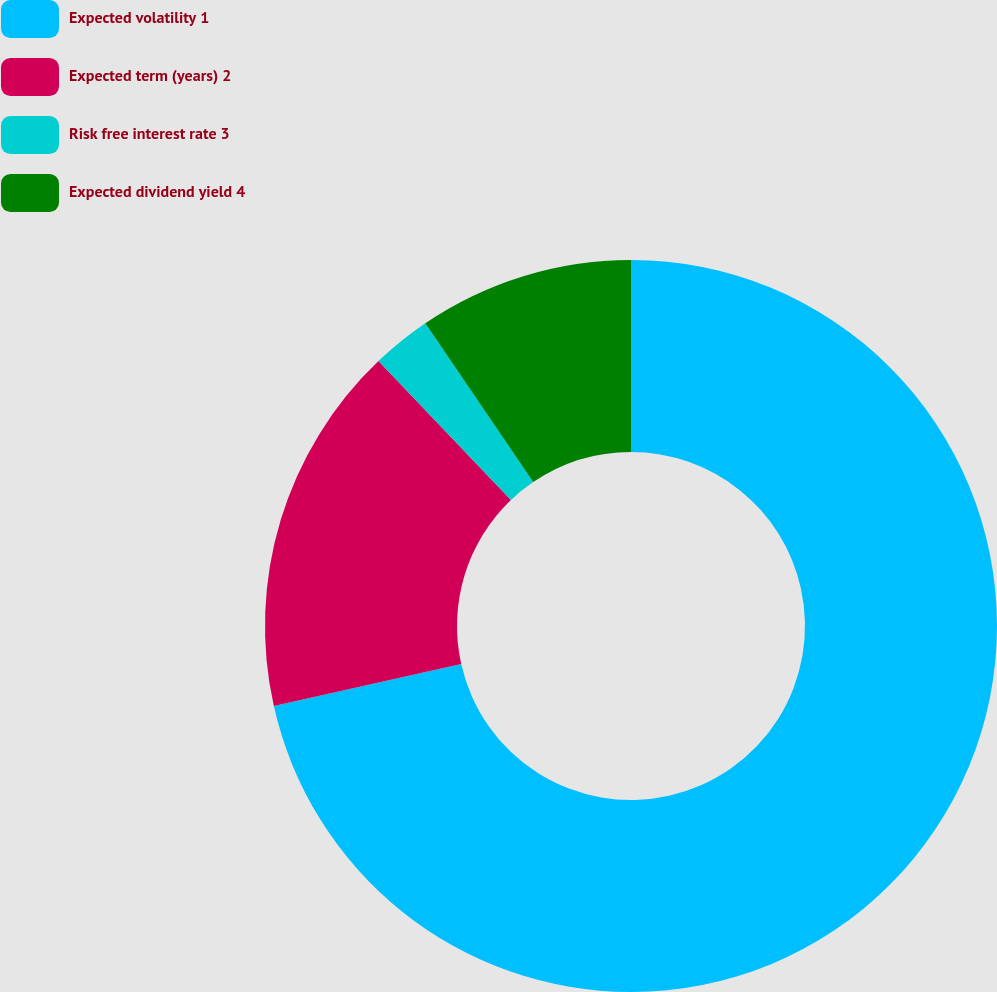Convert chart to OTSL. <chart><loc_0><loc_0><loc_500><loc_500><pie_chart><fcel>Expected volatility 1<fcel>Expected term (years) 2<fcel>Risk free interest rate 3<fcel>Expected dividend yield 4<nl><fcel>71.49%<fcel>16.39%<fcel>2.62%<fcel>9.5%<nl></chart> 